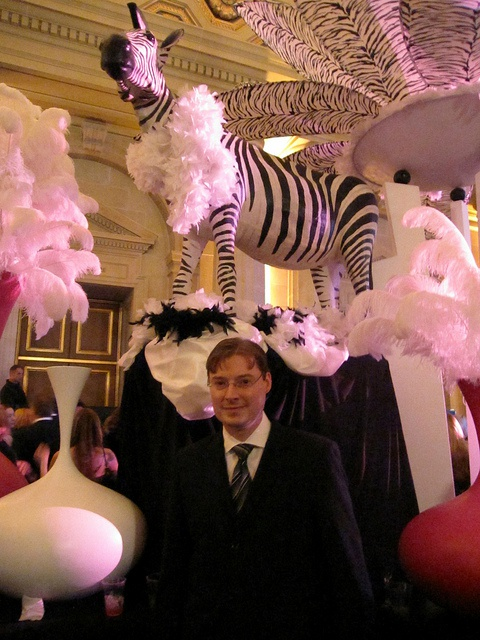Describe the objects in this image and their specific colors. I can see people in olive, black, maroon, and brown tones, zebra in olive, brown, black, maroon, and tan tones, people in olive, black, maroon, and brown tones, people in olive, black, maroon, and brown tones, and tie in olive, black, maroon, and gray tones in this image. 